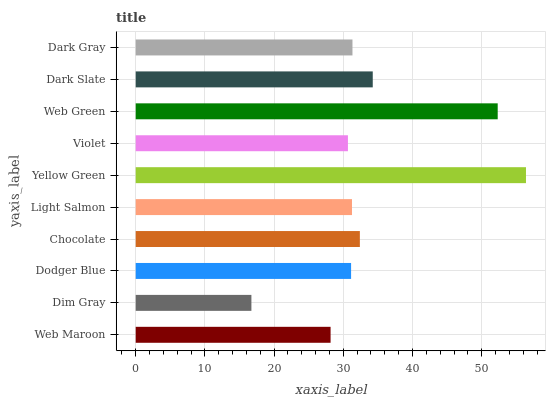Is Dim Gray the minimum?
Answer yes or no. Yes. Is Yellow Green the maximum?
Answer yes or no. Yes. Is Dodger Blue the minimum?
Answer yes or no. No. Is Dodger Blue the maximum?
Answer yes or no. No. Is Dodger Blue greater than Dim Gray?
Answer yes or no. Yes. Is Dim Gray less than Dodger Blue?
Answer yes or no. Yes. Is Dim Gray greater than Dodger Blue?
Answer yes or no. No. Is Dodger Blue less than Dim Gray?
Answer yes or no. No. Is Dark Gray the high median?
Answer yes or no. Yes. Is Light Salmon the low median?
Answer yes or no. Yes. Is Light Salmon the high median?
Answer yes or no. No. Is Dark Slate the low median?
Answer yes or no. No. 